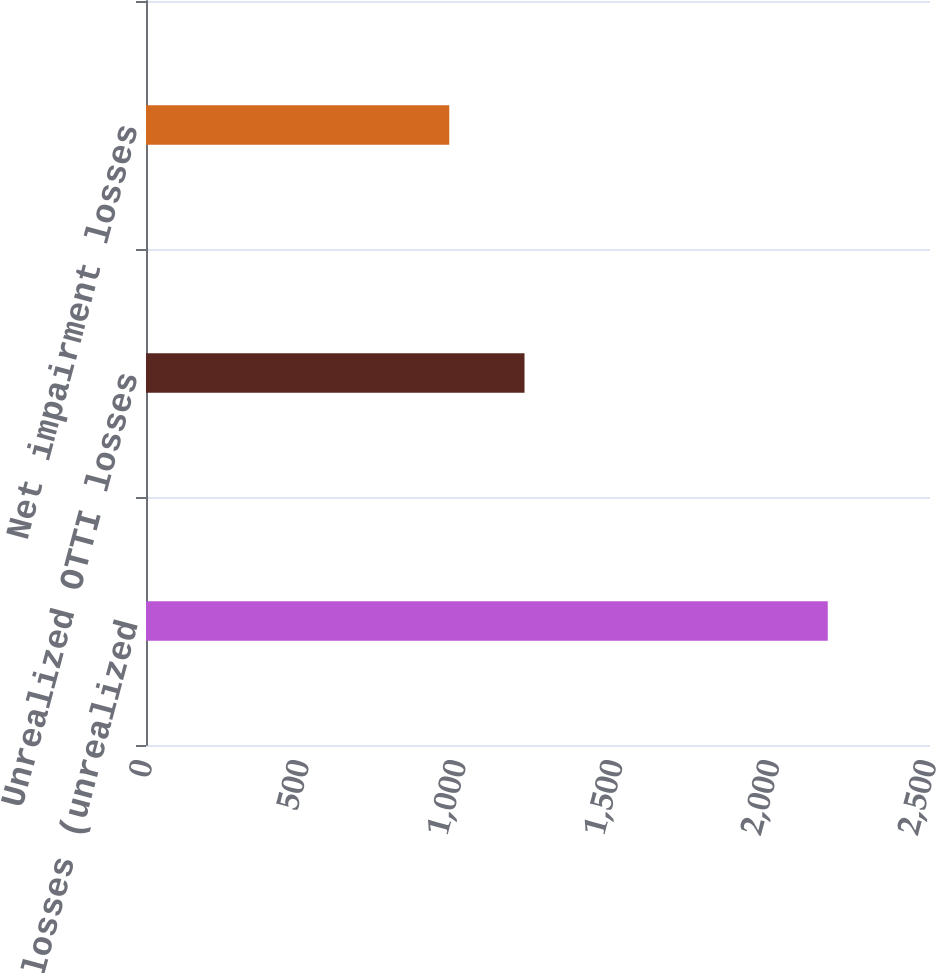Convert chart. <chart><loc_0><loc_0><loc_500><loc_500><bar_chart><fcel>Total OTTI losses (unrealized<fcel>Unrealized OTTI losses<fcel>Net impairment losses<nl><fcel>2174<fcel>1207<fcel>967<nl></chart> 